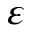Convert formula to latex. <formula><loc_0><loc_0><loc_500><loc_500>\varepsilon</formula> 